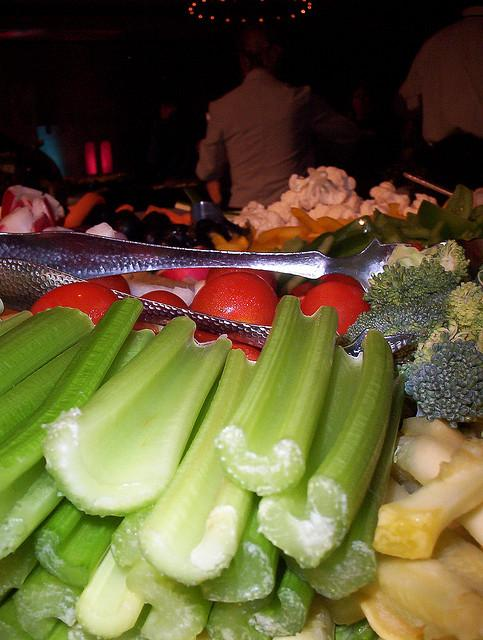What type of silver utensil sits atop the salad bar?

Choices:
A) spoon
B) tongs
C) knife
D) fork tongs 